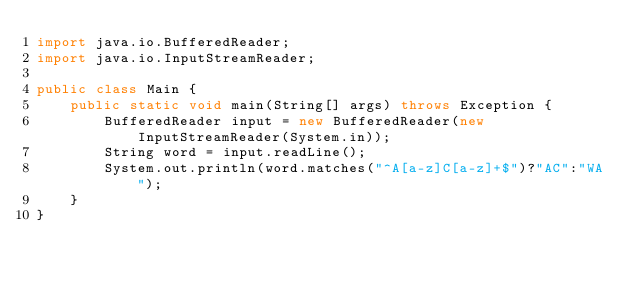<code> <loc_0><loc_0><loc_500><loc_500><_Java_>import java.io.BufferedReader;
import java.io.InputStreamReader;

public class Main {
    public static void main(String[] args) throws Exception {
        BufferedReader input = new BufferedReader(new InputStreamReader(System.in));
        String word = input.readLine();
        System.out.println(word.matches("^A[a-z]C[a-z]+$")?"AC":"WA");
    }
}
</code> 